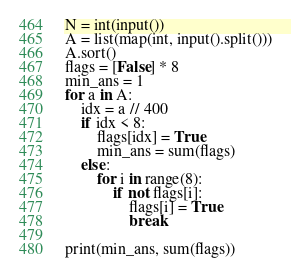<code> <loc_0><loc_0><loc_500><loc_500><_Python_>N = int(input())
A = list(map(int, input().split()))
A.sort()
flags = [False] * 8
min_ans = 1
for a in A:
    idx = a // 400
    if idx < 8:
        flags[idx] = True
        min_ans = sum(flags)
    else:
        for i in range(8):
            if not flags[i]:
                flags[i] = True
                break

print(min_ans, sum(flags))

</code> 